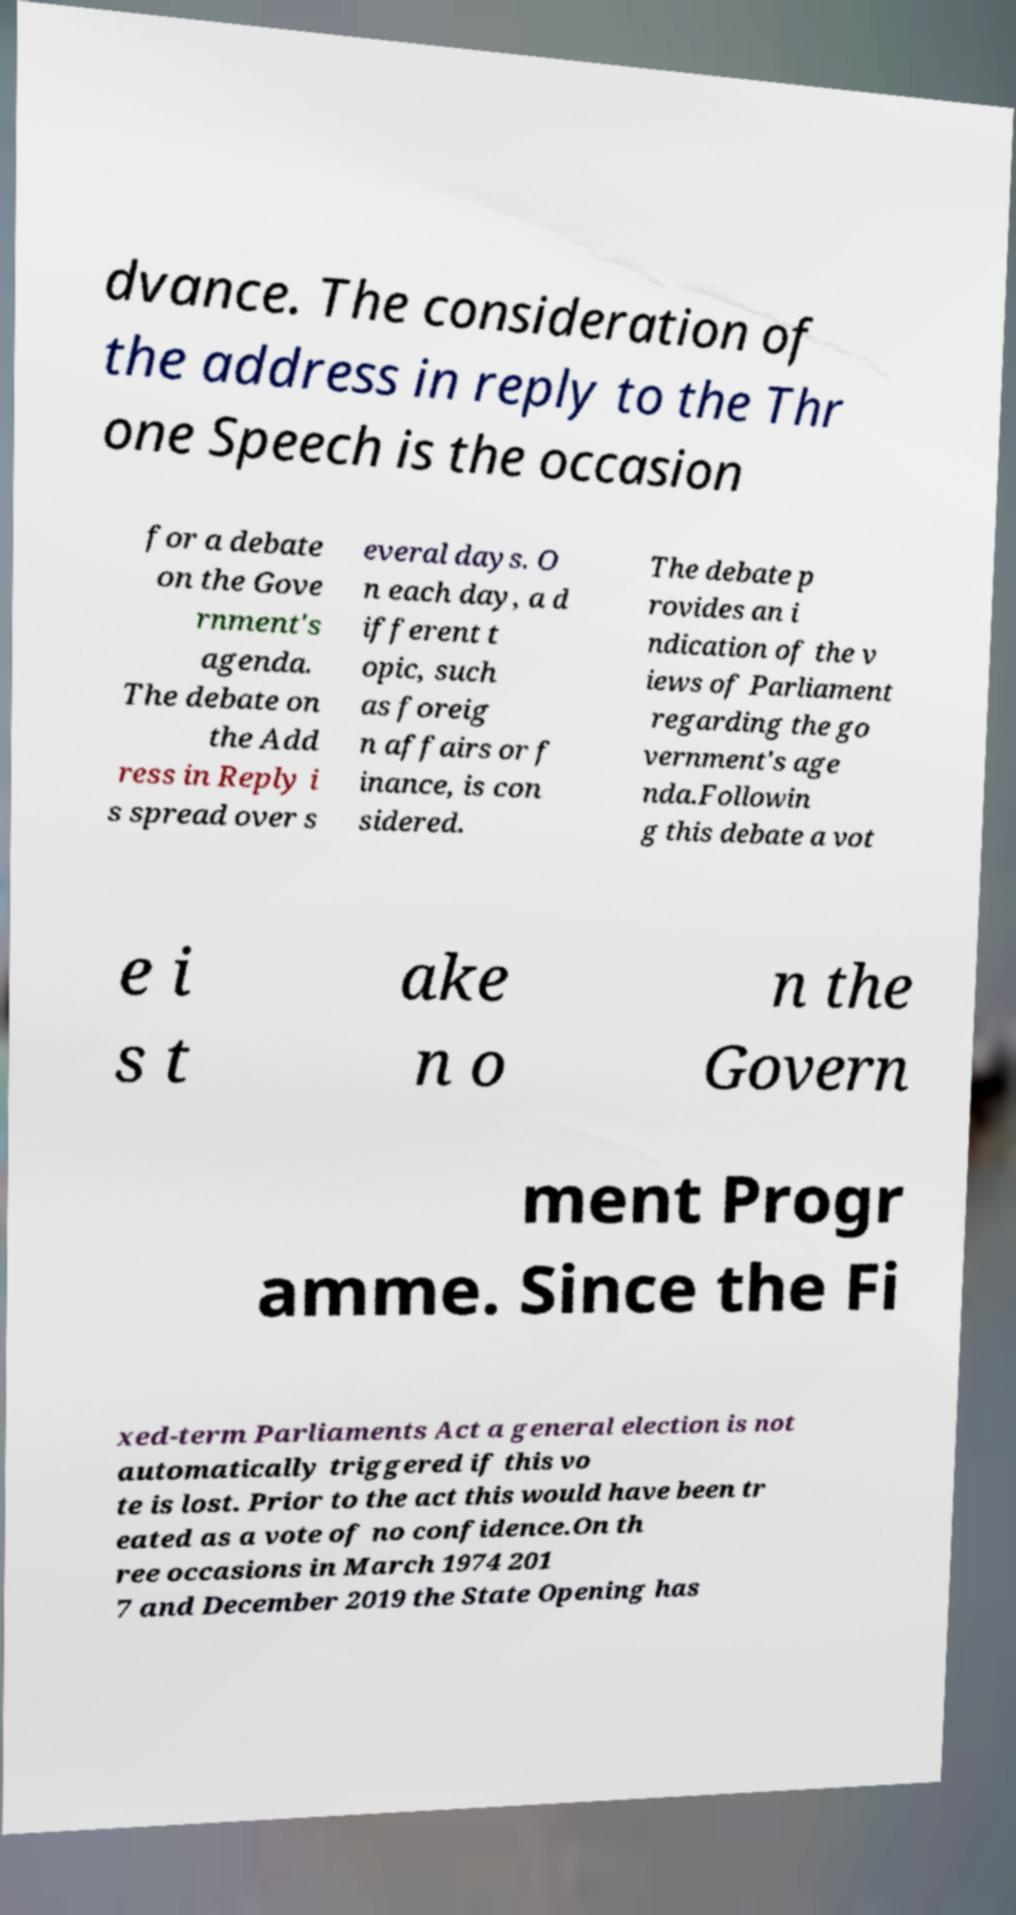Could you extract and type out the text from this image? dvance. The consideration of the address in reply to the Thr one Speech is the occasion for a debate on the Gove rnment's agenda. The debate on the Add ress in Reply i s spread over s everal days. O n each day, a d ifferent t opic, such as foreig n affairs or f inance, is con sidered. The debate p rovides an i ndication of the v iews of Parliament regarding the go vernment's age nda.Followin g this debate a vot e i s t ake n o n the Govern ment Progr amme. Since the Fi xed-term Parliaments Act a general election is not automatically triggered if this vo te is lost. Prior to the act this would have been tr eated as a vote of no confidence.On th ree occasions in March 1974 201 7 and December 2019 the State Opening has 